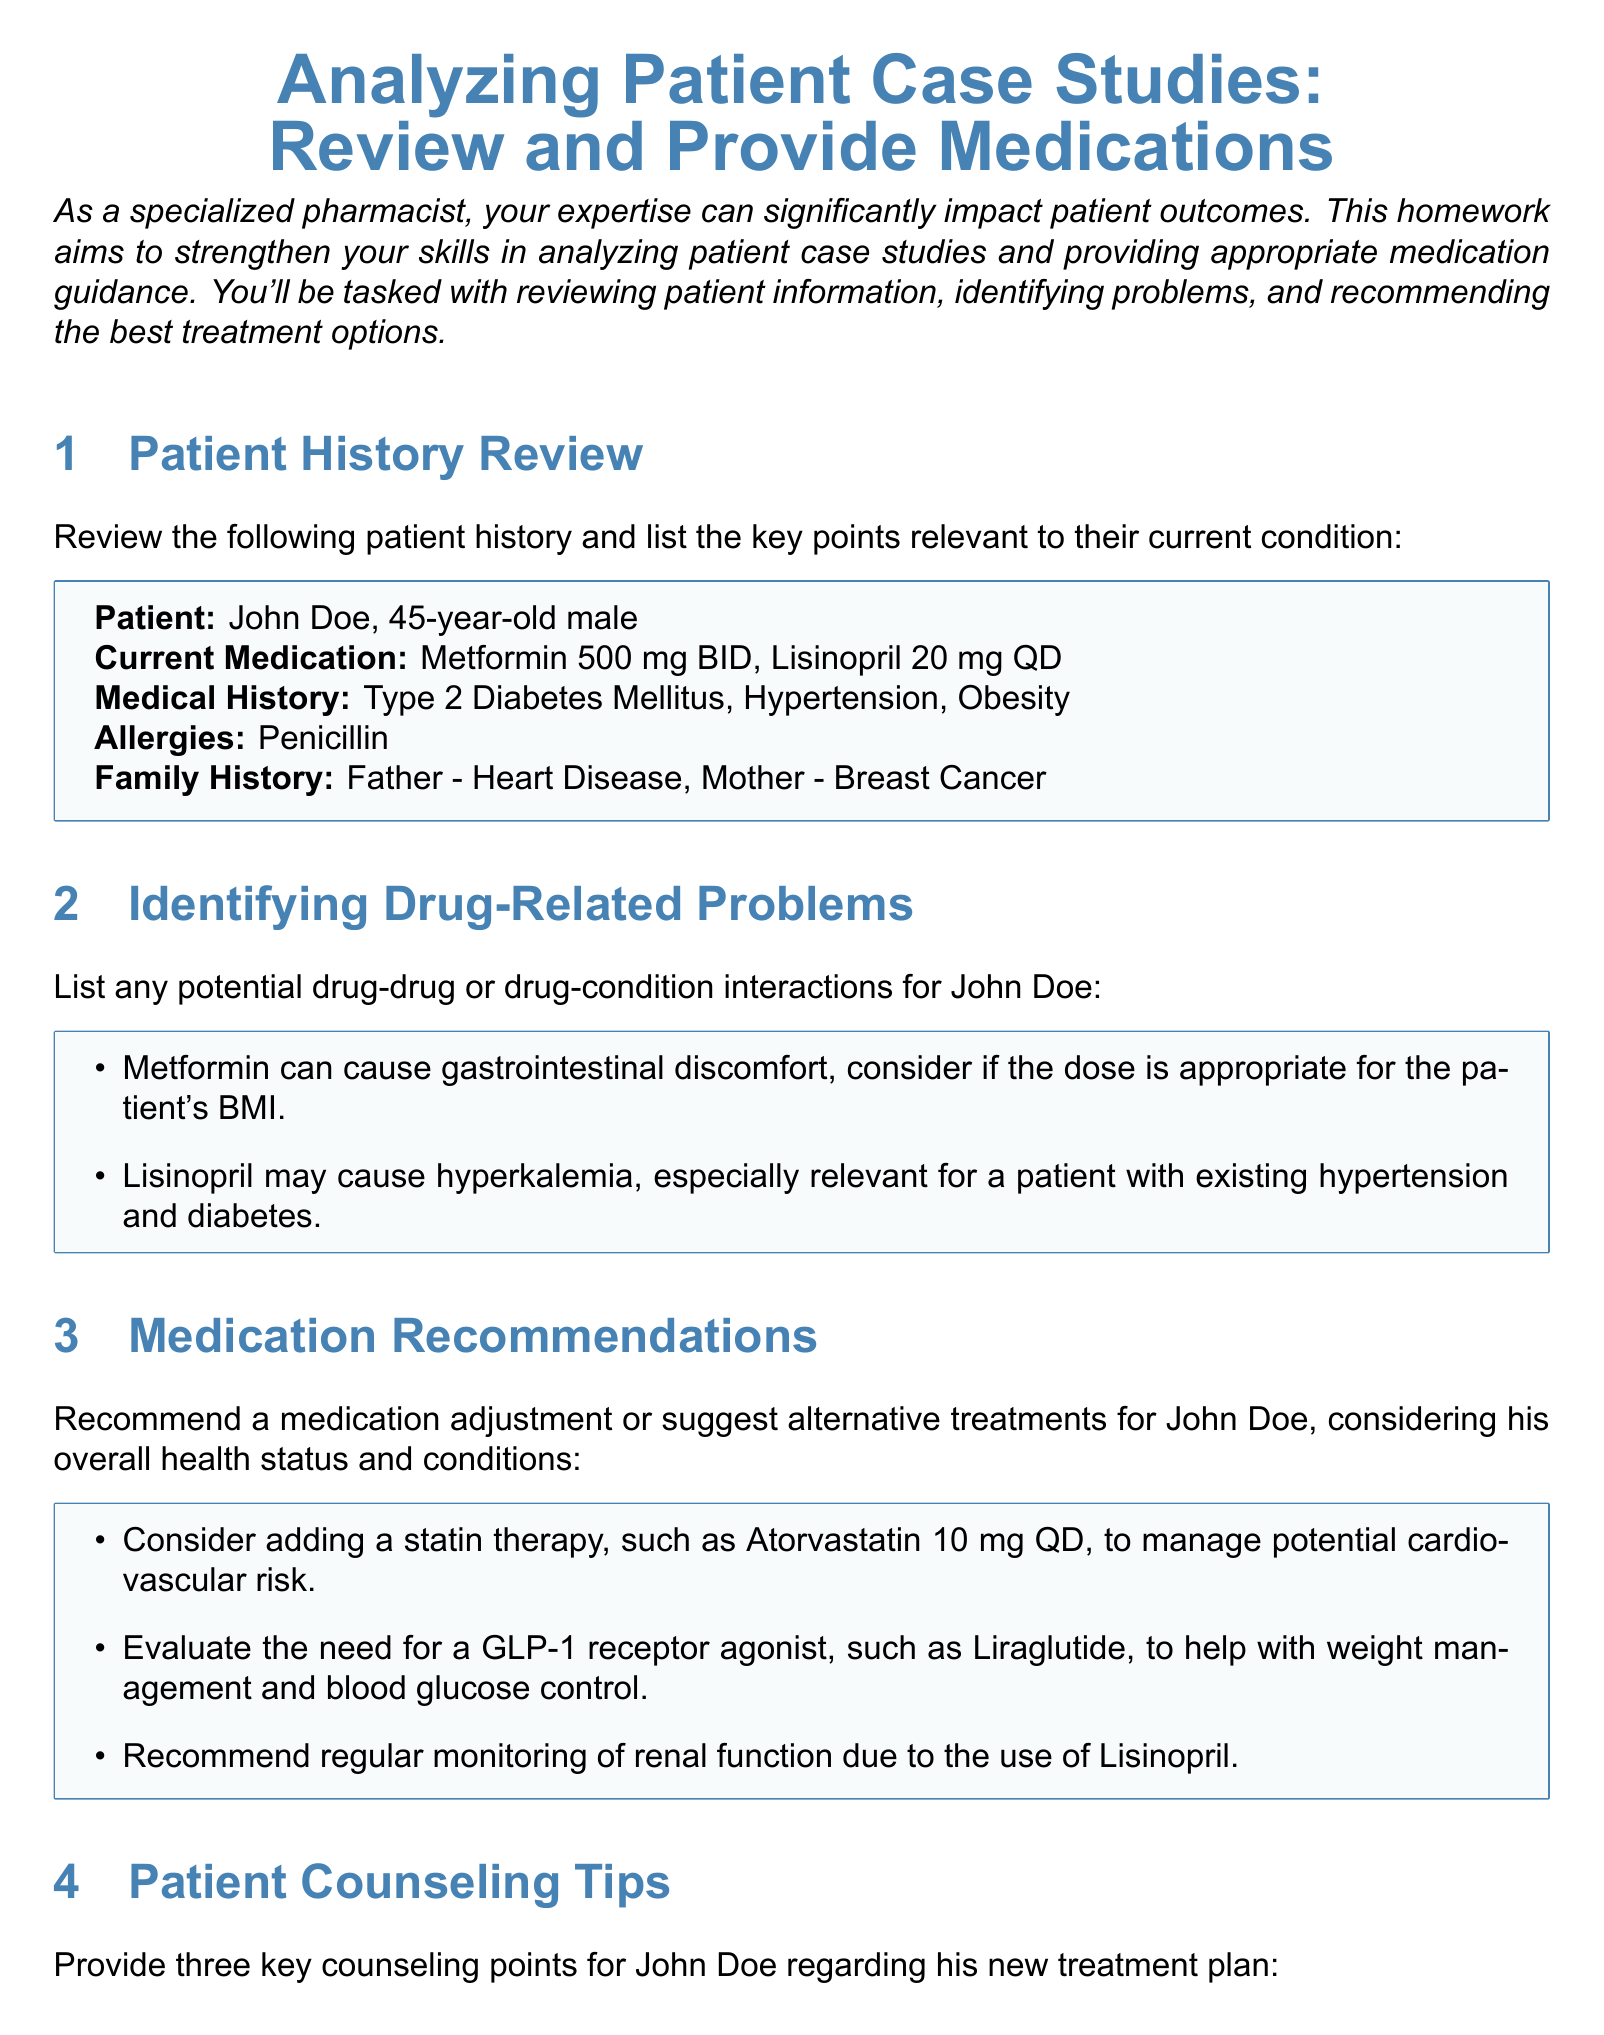What is the patient's name? The patient's name is specified in the document as John Doe.
Answer: John Doe What is the current medication for John Doe? The document lists the medications taken by John Doe, which are Metformin 500 mg BID and Lisinopril 20 mg QD.
Answer: Metformin 500 mg BID, Lisinopril 20 mg QD What medical condition does John Doe have? The document includes a list of medical conditions, specifically Type 2 Diabetes Mellitus, Hypertension, and Obesity.
Answer: Type 2 Diabetes Mellitus, Hypertension, Obesity What is a potential drug-related problem identified in the case? The document indicates that Lisinopril may cause hyperkalemia, particularly relevant for a patient with existing hypertension and diabetes.
Answer: Hyperkalemia What medication is recommended to manage cardiovascular risk? The document suggests adding Atorvastatin 10 mg QD as a recommendation for John Doe's treatment plan.
Answer: Atorvastatin 10 mg QD What type of medication is suggested for weight management? The document mentions a GLP-1 receptor agonist, specifically Liraglutide, for weight management and blood glucose control.
Answer: Liraglutide How many counseling points were provided for John Doe? The document includes three key counseling points regarding John Doe's new treatment plan.
Answer: Three What lifestyle modification is encouraged for John Doe? The document recommends dietary changes and regular exercise as lifestyle modifications to help manage diabetes and hypertension.
Answer: Dietary changes and regular exercise 